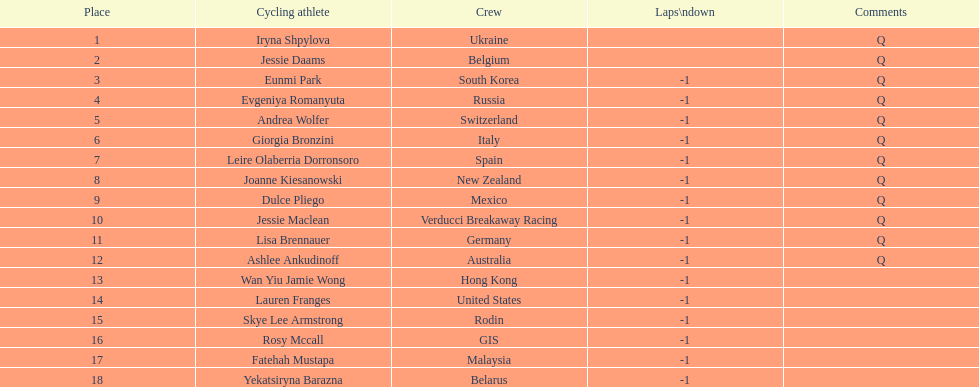What two cyclists come from teams with no laps down? Iryna Shpylova, Jessie Daams. 